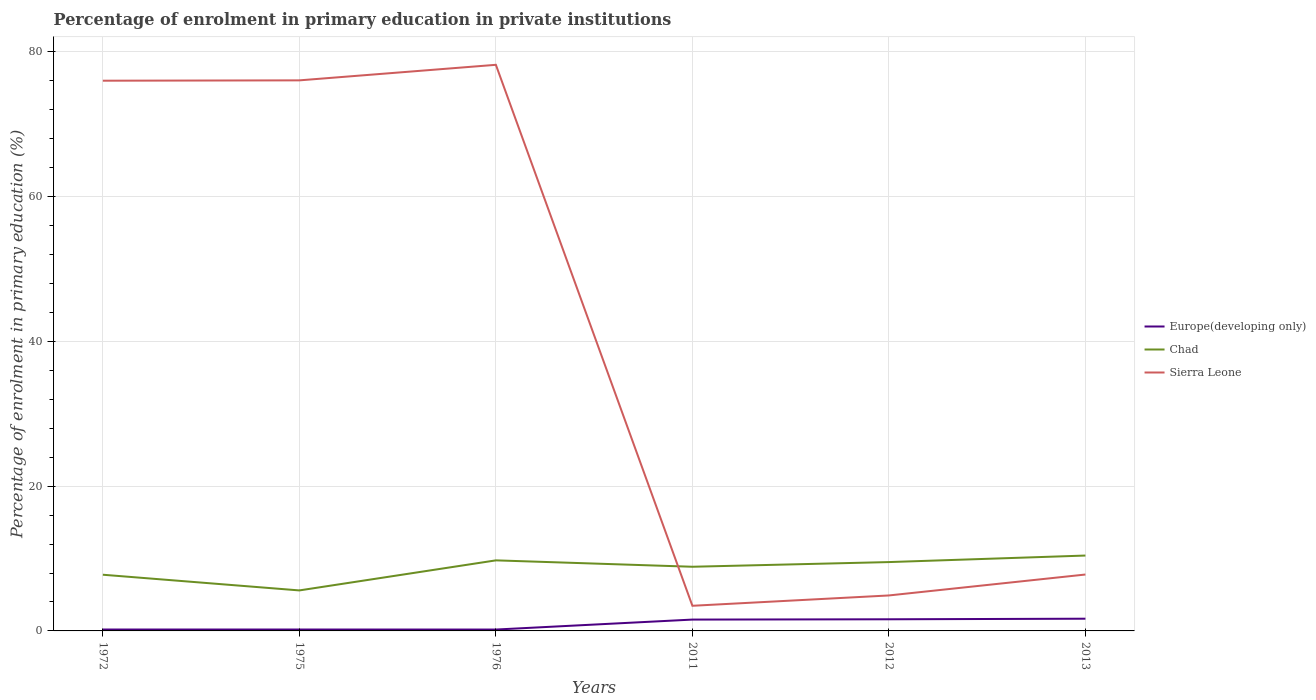Does the line corresponding to Chad intersect with the line corresponding to Sierra Leone?
Your answer should be very brief. Yes. Is the number of lines equal to the number of legend labels?
Your answer should be compact. Yes. Across all years, what is the maximum percentage of enrolment in primary education in Sierra Leone?
Your answer should be compact. 3.47. In which year was the percentage of enrolment in primary education in Europe(developing only) maximum?
Provide a short and direct response. 1976. What is the total percentage of enrolment in primary education in Chad in the graph?
Your answer should be very brief. -0.67. What is the difference between the highest and the second highest percentage of enrolment in primary education in Sierra Leone?
Offer a terse response. 74.72. Does the graph contain any zero values?
Keep it short and to the point. No. Does the graph contain grids?
Your answer should be compact. Yes. Where does the legend appear in the graph?
Provide a succinct answer. Center right. How are the legend labels stacked?
Your response must be concise. Vertical. What is the title of the graph?
Give a very brief answer. Percentage of enrolment in primary education in private institutions. What is the label or title of the Y-axis?
Your answer should be compact. Percentage of enrolment in primary education (%). What is the Percentage of enrolment in primary education (%) of Europe(developing only) in 1972?
Ensure brevity in your answer.  0.19. What is the Percentage of enrolment in primary education (%) of Chad in 1972?
Your answer should be compact. 7.76. What is the Percentage of enrolment in primary education (%) of Sierra Leone in 1972?
Ensure brevity in your answer.  76. What is the Percentage of enrolment in primary education (%) in Europe(developing only) in 1975?
Keep it short and to the point. 0.19. What is the Percentage of enrolment in primary education (%) in Chad in 1975?
Make the answer very short. 5.59. What is the Percentage of enrolment in primary education (%) of Sierra Leone in 1975?
Your answer should be compact. 76.05. What is the Percentage of enrolment in primary education (%) of Europe(developing only) in 1976?
Provide a succinct answer. 0.19. What is the Percentage of enrolment in primary education (%) in Chad in 1976?
Offer a terse response. 9.75. What is the Percentage of enrolment in primary education (%) of Sierra Leone in 1976?
Keep it short and to the point. 78.19. What is the Percentage of enrolment in primary education (%) in Europe(developing only) in 2011?
Ensure brevity in your answer.  1.57. What is the Percentage of enrolment in primary education (%) in Chad in 2011?
Provide a short and direct response. 8.86. What is the Percentage of enrolment in primary education (%) of Sierra Leone in 2011?
Offer a terse response. 3.47. What is the Percentage of enrolment in primary education (%) in Europe(developing only) in 2012?
Your response must be concise. 1.61. What is the Percentage of enrolment in primary education (%) of Chad in 2012?
Keep it short and to the point. 9.51. What is the Percentage of enrolment in primary education (%) in Sierra Leone in 2012?
Provide a short and direct response. 4.9. What is the Percentage of enrolment in primary education (%) of Europe(developing only) in 2013?
Your response must be concise. 1.69. What is the Percentage of enrolment in primary education (%) in Chad in 2013?
Offer a very short reply. 10.41. What is the Percentage of enrolment in primary education (%) in Sierra Leone in 2013?
Offer a terse response. 7.79. Across all years, what is the maximum Percentage of enrolment in primary education (%) in Europe(developing only)?
Keep it short and to the point. 1.69. Across all years, what is the maximum Percentage of enrolment in primary education (%) of Chad?
Offer a terse response. 10.41. Across all years, what is the maximum Percentage of enrolment in primary education (%) in Sierra Leone?
Keep it short and to the point. 78.19. Across all years, what is the minimum Percentage of enrolment in primary education (%) of Europe(developing only)?
Your answer should be very brief. 0.19. Across all years, what is the minimum Percentage of enrolment in primary education (%) in Chad?
Your answer should be very brief. 5.59. Across all years, what is the minimum Percentage of enrolment in primary education (%) in Sierra Leone?
Offer a terse response. 3.47. What is the total Percentage of enrolment in primary education (%) of Europe(developing only) in the graph?
Offer a terse response. 5.44. What is the total Percentage of enrolment in primary education (%) of Chad in the graph?
Offer a very short reply. 51.89. What is the total Percentage of enrolment in primary education (%) of Sierra Leone in the graph?
Offer a very short reply. 246.4. What is the difference between the Percentage of enrolment in primary education (%) of Chad in 1972 and that in 1975?
Give a very brief answer. 2.17. What is the difference between the Percentage of enrolment in primary education (%) in Sierra Leone in 1972 and that in 1975?
Your answer should be very brief. -0.05. What is the difference between the Percentage of enrolment in primary education (%) of Europe(developing only) in 1972 and that in 1976?
Ensure brevity in your answer.  0. What is the difference between the Percentage of enrolment in primary education (%) of Chad in 1972 and that in 1976?
Offer a terse response. -1.98. What is the difference between the Percentage of enrolment in primary education (%) in Sierra Leone in 1972 and that in 1976?
Offer a very short reply. -2.19. What is the difference between the Percentage of enrolment in primary education (%) in Europe(developing only) in 1972 and that in 2011?
Provide a succinct answer. -1.37. What is the difference between the Percentage of enrolment in primary education (%) of Chad in 1972 and that in 2011?
Offer a terse response. -1.1. What is the difference between the Percentage of enrolment in primary education (%) of Sierra Leone in 1972 and that in 2011?
Provide a short and direct response. 72.53. What is the difference between the Percentage of enrolment in primary education (%) of Europe(developing only) in 1972 and that in 2012?
Your answer should be very brief. -1.41. What is the difference between the Percentage of enrolment in primary education (%) of Chad in 1972 and that in 2012?
Make the answer very short. -1.75. What is the difference between the Percentage of enrolment in primary education (%) in Sierra Leone in 1972 and that in 2012?
Provide a short and direct response. 71.1. What is the difference between the Percentage of enrolment in primary education (%) of Europe(developing only) in 1972 and that in 2013?
Provide a short and direct response. -1.49. What is the difference between the Percentage of enrolment in primary education (%) of Chad in 1972 and that in 2013?
Your answer should be very brief. -2.65. What is the difference between the Percentage of enrolment in primary education (%) of Sierra Leone in 1972 and that in 2013?
Offer a very short reply. 68.21. What is the difference between the Percentage of enrolment in primary education (%) of Europe(developing only) in 1975 and that in 1976?
Your answer should be compact. 0. What is the difference between the Percentage of enrolment in primary education (%) in Chad in 1975 and that in 1976?
Provide a short and direct response. -4.15. What is the difference between the Percentage of enrolment in primary education (%) of Sierra Leone in 1975 and that in 1976?
Ensure brevity in your answer.  -2.15. What is the difference between the Percentage of enrolment in primary education (%) of Europe(developing only) in 1975 and that in 2011?
Offer a terse response. -1.37. What is the difference between the Percentage of enrolment in primary education (%) of Chad in 1975 and that in 2011?
Your answer should be compact. -3.27. What is the difference between the Percentage of enrolment in primary education (%) of Sierra Leone in 1975 and that in 2011?
Provide a short and direct response. 72.57. What is the difference between the Percentage of enrolment in primary education (%) in Europe(developing only) in 1975 and that in 2012?
Give a very brief answer. -1.41. What is the difference between the Percentage of enrolment in primary education (%) of Chad in 1975 and that in 2012?
Keep it short and to the point. -3.91. What is the difference between the Percentage of enrolment in primary education (%) of Sierra Leone in 1975 and that in 2012?
Make the answer very short. 71.15. What is the difference between the Percentage of enrolment in primary education (%) in Europe(developing only) in 1975 and that in 2013?
Your answer should be compact. -1.49. What is the difference between the Percentage of enrolment in primary education (%) of Chad in 1975 and that in 2013?
Make the answer very short. -4.82. What is the difference between the Percentage of enrolment in primary education (%) of Sierra Leone in 1975 and that in 2013?
Your answer should be very brief. 68.26. What is the difference between the Percentage of enrolment in primary education (%) in Europe(developing only) in 1976 and that in 2011?
Give a very brief answer. -1.38. What is the difference between the Percentage of enrolment in primary education (%) of Chad in 1976 and that in 2011?
Keep it short and to the point. 0.88. What is the difference between the Percentage of enrolment in primary education (%) of Sierra Leone in 1976 and that in 2011?
Your response must be concise. 74.72. What is the difference between the Percentage of enrolment in primary education (%) in Europe(developing only) in 1976 and that in 2012?
Your answer should be compact. -1.42. What is the difference between the Percentage of enrolment in primary education (%) of Chad in 1976 and that in 2012?
Give a very brief answer. 0.24. What is the difference between the Percentage of enrolment in primary education (%) of Sierra Leone in 1976 and that in 2012?
Make the answer very short. 73.29. What is the difference between the Percentage of enrolment in primary education (%) in Europe(developing only) in 1976 and that in 2013?
Ensure brevity in your answer.  -1.5. What is the difference between the Percentage of enrolment in primary education (%) in Chad in 1976 and that in 2013?
Your answer should be compact. -0.67. What is the difference between the Percentage of enrolment in primary education (%) in Sierra Leone in 1976 and that in 2013?
Ensure brevity in your answer.  70.4. What is the difference between the Percentage of enrolment in primary education (%) in Europe(developing only) in 2011 and that in 2012?
Offer a terse response. -0.04. What is the difference between the Percentage of enrolment in primary education (%) in Chad in 2011 and that in 2012?
Ensure brevity in your answer.  -0.64. What is the difference between the Percentage of enrolment in primary education (%) in Sierra Leone in 2011 and that in 2012?
Your answer should be very brief. -1.43. What is the difference between the Percentage of enrolment in primary education (%) in Europe(developing only) in 2011 and that in 2013?
Your answer should be compact. -0.12. What is the difference between the Percentage of enrolment in primary education (%) of Chad in 2011 and that in 2013?
Keep it short and to the point. -1.55. What is the difference between the Percentage of enrolment in primary education (%) in Sierra Leone in 2011 and that in 2013?
Your answer should be compact. -4.32. What is the difference between the Percentage of enrolment in primary education (%) in Europe(developing only) in 2012 and that in 2013?
Make the answer very short. -0.08. What is the difference between the Percentage of enrolment in primary education (%) in Chad in 2012 and that in 2013?
Your response must be concise. -0.9. What is the difference between the Percentage of enrolment in primary education (%) in Sierra Leone in 2012 and that in 2013?
Offer a very short reply. -2.89. What is the difference between the Percentage of enrolment in primary education (%) in Europe(developing only) in 1972 and the Percentage of enrolment in primary education (%) in Chad in 1975?
Offer a very short reply. -5.4. What is the difference between the Percentage of enrolment in primary education (%) in Europe(developing only) in 1972 and the Percentage of enrolment in primary education (%) in Sierra Leone in 1975?
Offer a terse response. -75.85. What is the difference between the Percentage of enrolment in primary education (%) in Chad in 1972 and the Percentage of enrolment in primary education (%) in Sierra Leone in 1975?
Provide a succinct answer. -68.29. What is the difference between the Percentage of enrolment in primary education (%) in Europe(developing only) in 1972 and the Percentage of enrolment in primary education (%) in Chad in 1976?
Give a very brief answer. -9.55. What is the difference between the Percentage of enrolment in primary education (%) of Europe(developing only) in 1972 and the Percentage of enrolment in primary education (%) of Sierra Leone in 1976?
Provide a succinct answer. -78. What is the difference between the Percentage of enrolment in primary education (%) of Chad in 1972 and the Percentage of enrolment in primary education (%) of Sierra Leone in 1976?
Provide a succinct answer. -70.43. What is the difference between the Percentage of enrolment in primary education (%) of Europe(developing only) in 1972 and the Percentage of enrolment in primary education (%) of Chad in 2011?
Keep it short and to the point. -8.67. What is the difference between the Percentage of enrolment in primary education (%) of Europe(developing only) in 1972 and the Percentage of enrolment in primary education (%) of Sierra Leone in 2011?
Keep it short and to the point. -3.28. What is the difference between the Percentage of enrolment in primary education (%) of Chad in 1972 and the Percentage of enrolment in primary education (%) of Sierra Leone in 2011?
Keep it short and to the point. 4.29. What is the difference between the Percentage of enrolment in primary education (%) of Europe(developing only) in 1972 and the Percentage of enrolment in primary education (%) of Chad in 2012?
Give a very brief answer. -9.31. What is the difference between the Percentage of enrolment in primary education (%) in Europe(developing only) in 1972 and the Percentage of enrolment in primary education (%) in Sierra Leone in 2012?
Ensure brevity in your answer.  -4.71. What is the difference between the Percentage of enrolment in primary education (%) in Chad in 1972 and the Percentage of enrolment in primary education (%) in Sierra Leone in 2012?
Provide a short and direct response. 2.86. What is the difference between the Percentage of enrolment in primary education (%) of Europe(developing only) in 1972 and the Percentage of enrolment in primary education (%) of Chad in 2013?
Your response must be concise. -10.22. What is the difference between the Percentage of enrolment in primary education (%) of Europe(developing only) in 1972 and the Percentage of enrolment in primary education (%) of Sierra Leone in 2013?
Make the answer very short. -7.6. What is the difference between the Percentage of enrolment in primary education (%) of Chad in 1972 and the Percentage of enrolment in primary education (%) of Sierra Leone in 2013?
Give a very brief answer. -0.03. What is the difference between the Percentage of enrolment in primary education (%) of Europe(developing only) in 1975 and the Percentage of enrolment in primary education (%) of Chad in 1976?
Your answer should be compact. -9.55. What is the difference between the Percentage of enrolment in primary education (%) of Europe(developing only) in 1975 and the Percentage of enrolment in primary education (%) of Sierra Leone in 1976?
Ensure brevity in your answer.  -78. What is the difference between the Percentage of enrolment in primary education (%) of Chad in 1975 and the Percentage of enrolment in primary education (%) of Sierra Leone in 1976?
Offer a terse response. -72.6. What is the difference between the Percentage of enrolment in primary education (%) in Europe(developing only) in 1975 and the Percentage of enrolment in primary education (%) in Chad in 2011?
Ensure brevity in your answer.  -8.67. What is the difference between the Percentage of enrolment in primary education (%) of Europe(developing only) in 1975 and the Percentage of enrolment in primary education (%) of Sierra Leone in 2011?
Make the answer very short. -3.28. What is the difference between the Percentage of enrolment in primary education (%) of Chad in 1975 and the Percentage of enrolment in primary education (%) of Sierra Leone in 2011?
Give a very brief answer. 2.12. What is the difference between the Percentage of enrolment in primary education (%) in Europe(developing only) in 1975 and the Percentage of enrolment in primary education (%) in Chad in 2012?
Offer a very short reply. -9.31. What is the difference between the Percentage of enrolment in primary education (%) of Europe(developing only) in 1975 and the Percentage of enrolment in primary education (%) of Sierra Leone in 2012?
Give a very brief answer. -4.71. What is the difference between the Percentage of enrolment in primary education (%) in Chad in 1975 and the Percentage of enrolment in primary education (%) in Sierra Leone in 2012?
Keep it short and to the point. 0.69. What is the difference between the Percentage of enrolment in primary education (%) in Europe(developing only) in 1975 and the Percentage of enrolment in primary education (%) in Chad in 2013?
Give a very brief answer. -10.22. What is the difference between the Percentage of enrolment in primary education (%) in Europe(developing only) in 1975 and the Percentage of enrolment in primary education (%) in Sierra Leone in 2013?
Keep it short and to the point. -7.6. What is the difference between the Percentage of enrolment in primary education (%) of Chad in 1975 and the Percentage of enrolment in primary education (%) of Sierra Leone in 2013?
Your answer should be very brief. -2.19. What is the difference between the Percentage of enrolment in primary education (%) in Europe(developing only) in 1976 and the Percentage of enrolment in primary education (%) in Chad in 2011?
Make the answer very short. -8.67. What is the difference between the Percentage of enrolment in primary education (%) in Europe(developing only) in 1976 and the Percentage of enrolment in primary education (%) in Sierra Leone in 2011?
Your response must be concise. -3.28. What is the difference between the Percentage of enrolment in primary education (%) of Chad in 1976 and the Percentage of enrolment in primary education (%) of Sierra Leone in 2011?
Provide a succinct answer. 6.27. What is the difference between the Percentage of enrolment in primary education (%) in Europe(developing only) in 1976 and the Percentage of enrolment in primary education (%) in Chad in 2012?
Offer a very short reply. -9.32. What is the difference between the Percentage of enrolment in primary education (%) in Europe(developing only) in 1976 and the Percentage of enrolment in primary education (%) in Sierra Leone in 2012?
Make the answer very short. -4.71. What is the difference between the Percentage of enrolment in primary education (%) of Chad in 1976 and the Percentage of enrolment in primary education (%) of Sierra Leone in 2012?
Ensure brevity in your answer.  4.85. What is the difference between the Percentage of enrolment in primary education (%) in Europe(developing only) in 1976 and the Percentage of enrolment in primary education (%) in Chad in 2013?
Keep it short and to the point. -10.22. What is the difference between the Percentage of enrolment in primary education (%) in Europe(developing only) in 1976 and the Percentage of enrolment in primary education (%) in Sierra Leone in 2013?
Give a very brief answer. -7.6. What is the difference between the Percentage of enrolment in primary education (%) in Chad in 1976 and the Percentage of enrolment in primary education (%) in Sierra Leone in 2013?
Ensure brevity in your answer.  1.96. What is the difference between the Percentage of enrolment in primary education (%) in Europe(developing only) in 2011 and the Percentage of enrolment in primary education (%) in Chad in 2012?
Provide a succinct answer. -7.94. What is the difference between the Percentage of enrolment in primary education (%) of Europe(developing only) in 2011 and the Percentage of enrolment in primary education (%) of Sierra Leone in 2012?
Keep it short and to the point. -3.33. What is the difference between the Percentage of enrolment in primary education (%) of Chad in 2011 and the Percentage of enrolment in primary education (%) of Sierra Leone in 2012?
Your answer should be very brief. 3.96. What is the difference between the Percentage of enrolment in primary education (%) of Europe(developing only) in 2011 and the Percentage of enrolment in primary education (%) of Chad in 2013?
Keep it short and to the point. -8.84. What is the difference between the Percentage of enrolment in primary education (%) in Europe(developing only) in 2011 and the Percentage of enrolment in primary education (%) in Sierra Leone in 2013?
Provide a short and direct response. -6.22. What is the difference between the Percentage of enrolment in primary education (%) of Chad in 2011 and the Percentage of enrolment in primary education (%) of Sierra Leone in 2013?
Your answer should be very brief. 1.07. What is the difference between the Percentage of enrolment in primary education (%) in Europe(developing only) in 2012 and the Percentage of enrolment in primary education (%) in Chad in 2013?
Offer a terse response. -8.8. What is the difference between the Percentage of enrolment in primary education (%) of Europe(developing only) in 2012 and the Percentage of enrolment in primary education (%) of Sierra Leone in 2013?
Your answer should be compact. -6.18. What is the difference between the Percentage of enrolment in primary education (%) in Chad in 2012 and the Percentage of enrolment in primary education (%) in Sierra Leone in 2013?
Make the answer very short. 1.72. What is the average Percentage of enrolment in primary education (%) of Europe(developing only) per year?
Your answer should be very brief. 0.91. What is the average Percentage of enrolment in primary education (%) of Chad per year?
Give a very brief answer. 8.65. What is the average Percentage of enrolment in primary education (%) in Sierra Leone per year?
Provide a succinct answer. 41.07. In the year 1972, what is the difference between the Percentage of enrolment in primary education (%) of Europe(developing only) and Percentage of enrolment in primary education (%) of Chad?
Provide a succinct answer. -7.57. In the year 1972, what is the difference between the Percentage of enrolment in primary education (%) in Europe(developing only) and Percentage of enrolment in primary education (%) in Sierra Leone?
Offer a terse response. -75.81. In the year 1972, what is the difference between the Percentage of enrolment in primary education (%) in Chad and Percentage of enrolment in primary education (%) in Sierra Leone?
Offer a terse response. -68.24. In the year 1975, what is the difference between the Percentage of enrolment in primary education (%) of Europe(developing only) and Percentage of enrolment in primary education (%) of Chad?
Ensure brevity in your answer.  -5.4. In the year 1975, what is the difference between the Percentage of enrolment in primary education (%) of Europe(developing only) and Percentage of enrolment in primary education (%) of Sierra Leone?
Offer a terse response. -75.85. In the year 1975, what is the difference between the Percentage of enrolment in primary education (%) in Chad and Percentage of enrolment in primary education (%) in Sierra Leone?
Your response must be concise. -70.45. In the year 1976, what is the difference between the Percentage of enrolment in primary education (%) of Europe(developing only) and Percentage of enrolment in primary education (%) of Chad?
Your response must be concise. -9.56. In the year 1976, what is the difference between the Percentage of enrolment in primary education (%) of Europe(developing only) and Percentage of enrolment in primary education (%) of Sierra Leone?
Provide a succinct answer. -78. In the year 1976, what is the difference between the Percentage of enrolment in primary education (%) of Chad and Percentage of enrolment in primary education (%) of Sierra Leone?
Provide a succinct answer. -68.45. In the year 2011, what is the difference between the Percentage of enrolment in primary education (%) in Europe(developing only) and Percentage of enrolment in primary education (%) in Chad?
Keep it short and to the point. -7.3. In the year 2011, what is the difference between the Percentage of enrolment in primary education (%) of Europe(developing only) and Percentage of enrolment in primary education (%) of Sierra Leone?
Provide a succinct answer. -1.91. In the year 2011, what is the difference between the Percentage of enrolment in primary education (%) of Chad and Percentage of enrolment in primary education (%) of Sierra Leone?
Your response must be concise. 5.39. In the year 2012, what is the difference between the Percentage of enrolment in primary education (%) in Europe(developing only) and Percentage of enrolment in primary education (%) in Chad?
Your response must be concise. -7.9. In the year 2012, what is the difference between the Percentage of enrolment in primary education (%) in Europe(developing only) and Percentage of enrolment in primary education (%) in Sierra Leone?
Ensure brevity in your answer.  -3.29. In the year 2012, what is the difference between the Percentage of enrolment in primary education (%) of Chad and Percentage of enrolment in primary education (%) of Sierra Leone?
Offer a very short reply. 4.61. In the year 2013, what is the difference between the Percentage of enrolment in primary education (%) of Europe(developing only) and Percentage of enrolment in primary education (%) of Chad?
Offer a terse response. -8.72. In the year 2013, what is the difference between the Percentage of enrolment in primary education (%) in Europe(developing only) and Percentage of enrolment in primary education (%) in Sierra Leone?
Your answer should be very brief. -6.1. In the year 2013, what is the difference between the Percentage of enrolment in primary education (%) in Chad and Percentage of enrolment in primary education (%) in Sierra Leone?
Your answer should be compact. 2.62. What is the ratio of the Percentage of enrolment in primary education (%) in Europe(developing only) in 1972 to that in 1975?
Your answer should be compact. 1. What is the ratio of the Percentage of enrolment in primary education (%) in Chad in 1972 to that in 1975?
Offer a very short reply. 1.39. What is the ratio of the Percentage of enrolment in primary education (%) of Europe(developing only) in 1972 to that in 1976?
Offer a very short reply. 1.02. What is the ratio of the Percentage of enrolment in primary education (%) in Chad in 1972 to that in 1976?
Your response must be concise. 0.8. What is the ratio of the Percentage of enrolment in primary education (%) of Sierra Leone in 1972 to that in 1976?
Offer a very short reply. 0.97. What is the ratio of the Percentage of enrolment in primary education (%) in Europe(developing only) in 1972 to that in 2011?
Give a very brief answer. 0.12. What is the ratio of the Percentage of enrolment in primary education (%) in Chad in 1972 to that in 2011?
Offer a terse response. 0.88. What is the ratio of the Percentage of enrolment in primary education (%) in Sierra Leone in 1972 to that in 2011?
Your answer should be compact. 21.88. What is the ratio of the Percentage of enrolment in primary education (%) in Europe(developing only) in 1972 to that in 2012?
Give a very brief answer. 0.12. What is the ratio of the Percentage of enrolment in primary education (%) in Chad in 1972 to that in 2012?
Give a very brief answer. 0.82. What is the ratio of the Percentage of enrolment in primary education (%) in Sierra Leone in 1972 to that in 2012?
Provide a succinct answer. 15.51. What is the ratio of the Percentage of enrolment in primary education (%) in Europe(developing only) in 1972 to that in 2013?
Your answer should be very brief. 0.12. What is the ratio of the Percentage of enrolment in primary education (%) of Chad in 1972 to that in 2013?
Offer a very short reply. 0.75. What is the ratio of the Percentage of enrolment in primary education (%) in Sierra Leone in 1972 to that in 2013?
Your answer should be compact. 9.76. What is the ratio of the Percentage of enrolment in primary education (%) in Chad in 1975 to that in 1976?
Your answer should be compact. 0.57. What is the ratio of the Percentage of enrolment in primary education (%) of Sierra Leone in 1975 to that in 1976?
Your response must be concise. 0.97. What is the ratio of the Percentage of enrolment in primary education (%) of Europe(developing only) in 1975 to that in 2011?
Make the answer very short. 0.12. What is the ratio of the Percentage of enrolment in primary education (%) in Chad in 1975 to that in 2011?
Offer a terse response. 0.63. What is the ratio of the Percentage of enrolment in primary education (%) in Sierra Leone in 1975 to that in 2011?
Offer a very short reply. 21.9. What is the ratio of the Percentage of enrolment in primary education (%) in Europe(developing only) in 1975 to that in 2012?
Offer a very short reply. 0.12. What is the ratio of the Percentage of enrolment in primary education (%) in Chad in 1975 to that in 2012?
Offer a terse response. 0.59. What is the ratio of the Percentage of enrolment in primary education (%) in Sierra Leone in 1975 to that in 2012?
Keep it short and to the point. 15.52. What is the ratio of the Percentage of enrolment in primary education (%) in Europe(developing only) in 1975 to that in 2013?
Your answer should be very brief. 0.11. What is the ratio of the Percentage of enrolment in primary education (%) in Chad in 1975 to that in 2013?
Provide a succinct answer. 0.54. What is the ratio of the Percentage of enrolment in primary education (%) in Sierra Leone in 1975 to that in 2013?
Make the answer very short. 9.76. What is the ratio of the Percentage of enrolment in primary education (%) in Europe(developing only) in 1976 to that in 2011?
Ensure brevity in your answer.  0.12. What is the ratio of the Percentage of enrolment in primary education (%) of Chad in 1976 to that in 2011?
Ensure brevity in your answer.  1.1. What is the ratio of the Percentage of enrolment in primary education (%) in Sierra Leone in 1976 to that in 2011?
Give a very brief answer. 22.51. What is the ratio of the Percentage of enrolment in primary education (%) in Europe(developing only) in 1976 to that in 2012?
Make the answer very short. 0.12. What is the ratio of the Percentage of enrolment in primary education (%) in Chad in 1976 to that in 2012?
Offer a very short reply. 1.02. What is the ratio of the Percentage of enrolment in primary education (%) of Sierra Leone in 1976 to that in 2012?
Give a very brief answer. 15.96. What is the ratio of the Percentage of enrolment in primary education (%) of Europe(developing only) in 1976 to that in 2013?
Make the answer very short. 0.11. What is the ratio of the Percentage of enrolment in primary education (%) in Chad in 1976 to that in 2013?
Provide a succinct answer. 0.94. What is the ratio of the Percentage of enrolment in primary education (%) in Sierra Leone in 1976 to that in 2013?
Give a very brief answer. 10.04. What is the ratio of the Percentage of enrolment in primary education (%) in Chad in 2011 to that in 2012?
Your answer should be compact. 0.93. What is the ratio of the Percentage of enrolment in primary education (%) of Sierra Leone in 2011 to that in 2012?
Ensure brevity in your answer.  0.71. What is the ratio of the Percentage of enrolment in primary education (%) of Europe(developing only) in 2011 to that in 2013?
Ensure brevity in your answer.  0.93. What is the ratio of the Percentage of enrolment in primary education (%) in Chad in 2011 to that in 2013?
Provide a succinct answer. 0.85. What is the ratio of the Percentage of enrolment in primary education (%) in Sierra Leone in 2011 to that in 2013?
Your answer should be compact. 0.45. What is the ratio of the Percentage of enrolment in primary education (%) in Europe(developing only) in 2012 to that in 2013?
Provide a succinct answer. 0.95. What is the ratio of the Percentage of enrolment in primary education (%) of Chad in 2012 to that in 2013?
Offer a terse response. 0.91. What is the ratio of the Percentage of enrolment in primary education (%) of Sierra Leone in 2012 to that in 2013?
Give a very brief answer. 0.63. What is the difference between the highest and the second highest Percentage of enrolment in primary education (%) in Europe(developing only)?
Your answer should be compact. 0.08. What is the difference between the highest and the second highest Percentage of enrolment in primary education (%) of Chad?
Offer a terse response. 0.67. What is the difference between the highest and the second highest Percentage of enrolment in primary education (%) of Sierra Leone?
Your answer should be compact. 2.15. What is the difference between the highest and the lowest Percentage of enrolment in primary education (%) of Europe(developing only)?
Offer a terse response. 1.5. What is the difference between the highest and the lowest Percentage of enrolment in primary education (%) of Chad?
Give a very brief answer. 4.82. What is the difference between the highest and the lowest Percentage of enrolment in primary education (%) of Sierra Leone?
Provide a short and direct response. 74.72. 